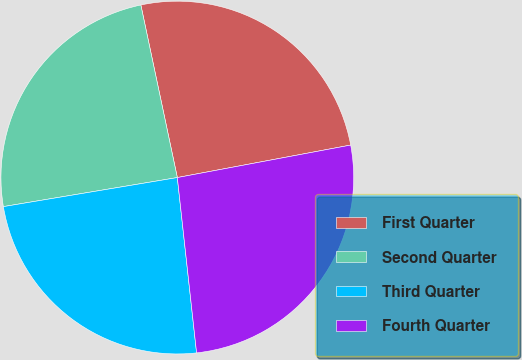Convert chart. <chart><loc_0><loc_0><loc_500><loc_500><pie_chart><fcel>First Quarter<fcel>Second Quarter<fcel>Third Quarter<fcel>Fourth Quarter<nl><fcel>25.37%<fcel>24.32%<fcel>24.11%<fcel>26.21%<nl></chart> 